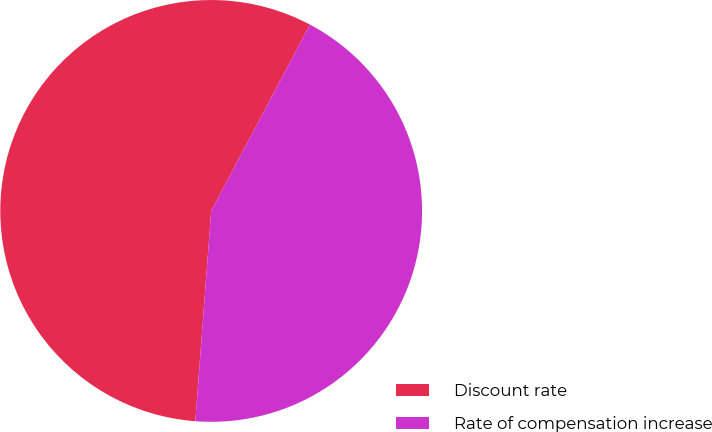Convert chart. <chart><loc_0><loc_0><loc_500><loc_500><pie_chart><fcel>Discount rate<fcel>Rate of compensation increase<nl><fcel>56.56%<fcel>43.44%<nl></chart> 